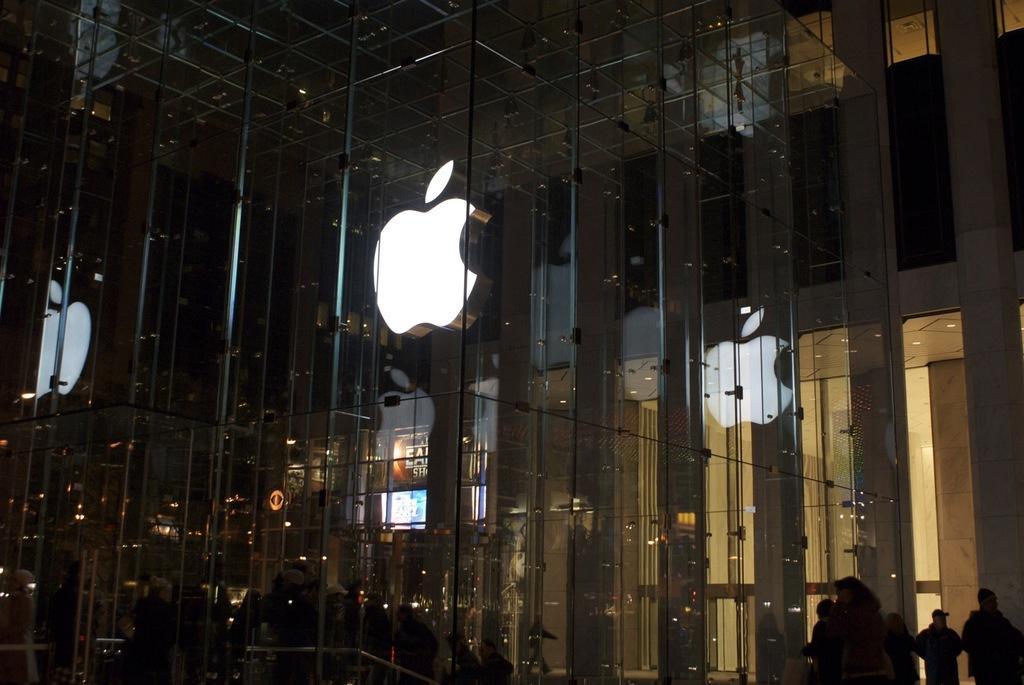Describe this image in one or two sentences. In this image there is a building having glass wall. There is a logo on the glass wall. Few persons are behind the glass wall. Right bottom there are few persons standing before the building. 